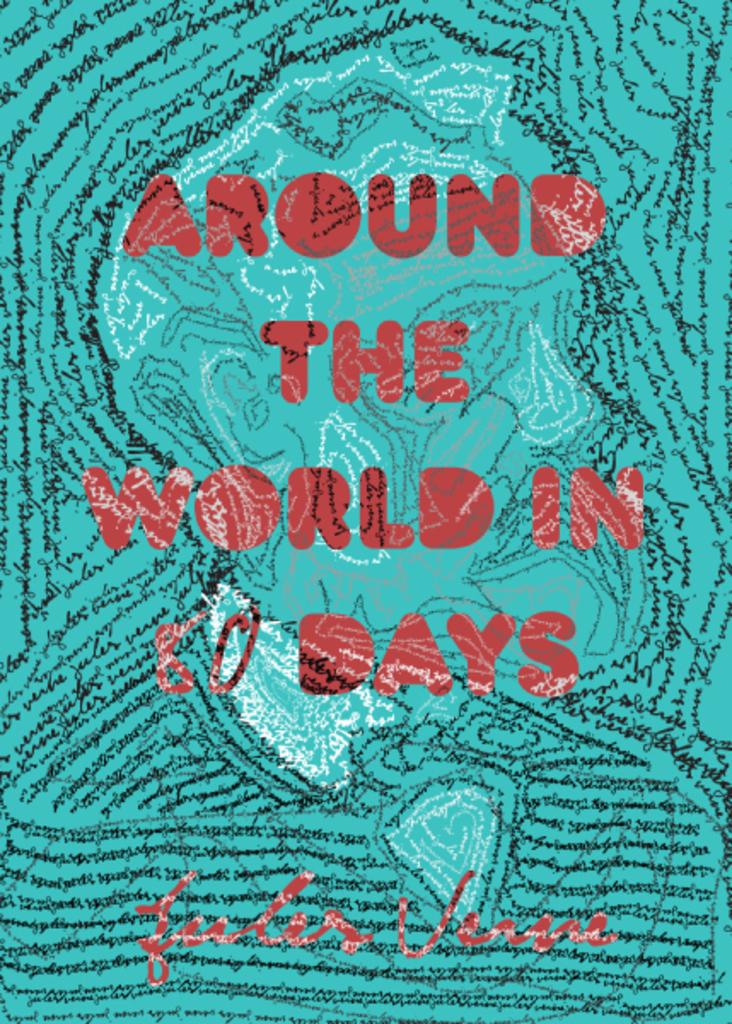What is the title of the book?
Your answer should be compact. Around the world in 80 days. 